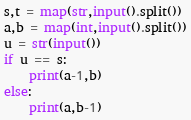Convert code to text. <code><loc_0><loc_0><loc_500><loc_500><_Python_>s,t = map(str,input().split())
a,b = map(int,input().split())
u = str(input())
if u == s:
    print(a-1,b)
else:
    print(a,b-1)
</code> 